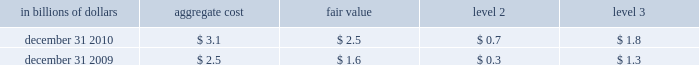The significant changes from december 31 , 2008 to december 31 , 2009 in level 3 assets and liabilities are due to : a net decrease in trading securities of $ 10.8 billion that was driven by : 2022 net transfers of $ 6.5 billion , due mainly to the transfer of debt 2013 securities from level 3 to level 2 due to increased liquidity and pricing transparency ; and net settlements of $ 5.8 billion , due primarily to the liquidations of 2013 subprime securities of $ 4.1 billion .
The change in net trading derivatives driven by : 2022 a net loss of $ 4.9 billion relating to complex derivative contracts , 2013 such as those linked to credit , equity and commodity exposures .
These losses include both realized and unrealized losses during 2009 and are partially offset by gains recognized in instruments that have been classified in levels 1 and 2 ; and net increase in derivative assets of $ 4.3 billion , which includes cash 2013 settlements of derivative contracts in an unrealized loss position , notably those linked to subprime exposures .
The decrease in level 3 investments of $ 6.9 billion primarily 2022 resulted from : a reduction of $ 5.0 billion , due mainly to paydowns on debt 2013 securities and sales of private equity investments ; the net transfer of investment securities from level 3 to level 2 2013 of $ 1.5 billion , due to increased availability of observable pricing inputs ; and net losses recognized of $ 0.4 billion due mainly to losses on non- 2013 marketable equity securities including write-downs on private equity investments .
The decrease in securities sold under agreements to repurchase of 2022 $ 9.1 billion is driven by a $ 8.6 billion net transfers from level 3 to level 2 as effective maturity dates on structured repos have shortened .
The decrease in long-term debt of $ 1.5 billion is driven mainly by 2022 $ 1.3 billion of net terminations of structured notes .
Transfers between level 1 and level 2 of the fair value hierarchy the company did not have any significant transfers of assets or liabilities between levels 1 and 2 of the fair value hierarchy during 2010 .
Items measured at fair value on a nonrecurring basis certain assets and liabilities are measured at fair value on a nonrecurring basis and therefore are not included in the tables above .
These include assets measured at cost that have been written down to fair value during the periods as a result of an impairment .
In addition , these assets include loans held-for-sale that are measured at locom that were recognized at fair value below cost at the end of the period .
The fair value of loans measured on a locom basis is determined where possible using quoted secondary-market prices .
Such loans are generally classified as level 2 of the fair value hierarchy given the level of activity in the market and the frequency of available quotes .
If no such quoted price exists , the fair value of a loan is determined using quoted prices for a similar asset or assets , adjusted for the specific attributes of that loan .
The table presents all loans held-for-sale that are carried at locom as of december 31 , 2010 and 2009 : in billions of dollars aggregate cost fair value level 2 level 3 .

What was the growth rate of the loans held-for-sale that are carried at locom from 2009 to 2010? 
Computations: ((2.5 / 1.6) / 1.6)
Answer: 0.97656. 